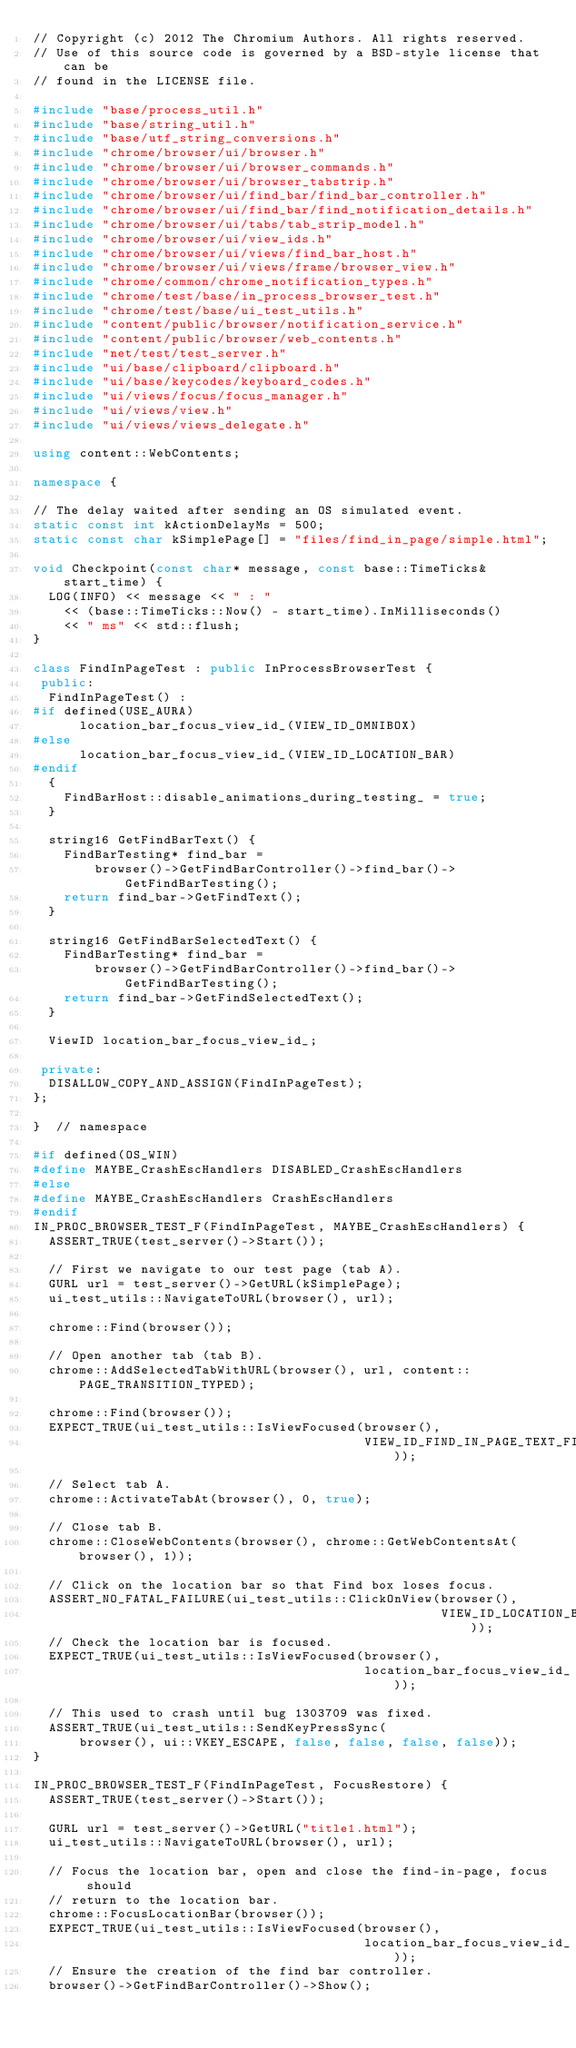Convert code to text. <code><loc_0><loc_0><loc_500><loc_500><_C++_>// Copyright (c) 2012 The Chromium Authors. All rights reserved.
// Use of this source code is governed by a BSD-style license that can be
// found in the LICENSE file.

#include "base/process_util.h"
#include "base/string_util.h"
#include "base/utf_string_conversions.h"
#include "chrome/browser/ui/browser.h"
#include "chrome/browser/ui/browser_commands.h"
#include "chrome/browser/ui/browser_tabstrip.h"
#include "chrome/browser/ui/find_bar/find_bar_controller.h"
#include "chrome/browser/ui/find_bar/find_notification_details.h"
#include "chrome/browser/ui/tabs/tab_strip_model.h"
#include "chrome/browser/ui/view_ids.h"
#include "chrome/browser/ui/views/find_bar_host.h"
#include "chrome/browser/ui/views/frame/browser_view.h"
#include "chrome/common/chrome_notification_types.h"
#include "chrome/test/base/in_process_browser_test.h"
#include "chrome/test/base/ui_test_utils.h"
#include "content/public/browser/notification_service.h"
#include "content/public/browser/web_contents.h"
#include "net/test/test_server.h"
#include "ui/base/clipboard/clipboard.h"
#include "ui/base/keycodes/keyboard_codes.h"
#include "ui/views/focus/focus_manager.h"
#include "ui/views/view.h"
#include "ui/views/views_delegate.h"

using content::WebContents;

namespace {

// The delay waited after sending an OS simulated event.
static const int kActionDelayMs = 500;
static const char kSimplePage[] = "files/find_in_page/simple.html";

void Checkpoint(const char* message, const base::TimeTicks& start_time) {
  LOG(INFO) << message << " : "
    << (base::TimeTicks::Now() - start_time).InMilliseconds()
    << " ms" << std::flush;
}

class FindInPageTest : public InProcessBrowserTest {
 public:
  FindInPageTest() :
#if defined(USE_AURA)
      location_bar_focus_view_id_(VIEW_ID_OMNIBOX)
#else
      location_bar_focus_view_id_(VIEW_ID_LOCATION_BAR)
#endif
  {
    FindBarHost::disable_animations_during_testing_ = true;
  }

  string16 GetFindBarText() {
    FindBarTesting* find_bar =
        browser()->GetFindBarController()->find_bar()->GetFindBarTesting();
    return find_bar->GetFindText();
  }

  string16 GetFindBarSelectedText() {
    FindBarTesting* find_bar =
        browser()->GetFindBarController()->find_bar()->GetFindBarTesting();
    return find_bar->GetFindSelectedText();
  }

  ViewID location_bar_focus_view_id_;

 private:
  DISALLOW_COPY_AND_ASSIGN(FindInPageTest);
};

}  // namespace

#if defined(OS_WIN)
#define MAYBE_CrashEscHandlers DISABLED_CrashEscHandlers
#else
#define MAYBE_CrashEscHandlers CrashEscHandlers
#endif
IN_PROC_BROWSER_TEST_F(FindInPageTest, MAYBE_CrashEscHandlers) {
  ASSERT_TRUE(test_server()->Start());

  // First we navigate to our test page (tab A).
  GURL url = test_server()->GetURL(kSimplePage);
  ui_test_utils::NavigateToURL(browser(), url);

  chrome::Find(browser());

  // Open another tab (tab B).
  chrome::AddSelectedTabWithURL(browser(), url, content::PAGE_TRANSITION_TYPED);

  chrome::Find(browser());
  EXPECT_TRUE(ui_test_utils::IsViewFocused(browser(),
                                           VIEW_ID_FIND_IN_PAGE_TEXT_FIELD));

  // Select tab A.
  chrome::ActivateTabAt(browser(), 0, true);

  // Close tab B.
  chrome::CloseWebContents(browser(), chrome::GetWebContentsAt(browser(), 1));

  // Click on the location bar so that Find box loses focus.
  ASSERT_NO_FATAL_FAILURE(ui_test_utils::ClickOnView(browser(),
                                                     VIEW_ID_LOCATION_BAR));
  // Check the location bar is focused.
  EXPECT_TRUE(ui_test_utils::IsViewFocused(browser(),
                                           location_bar_focus_view_id_));

  // This used to crash until bug 1303709 was fixed.
  ASSERT_TRUE(ui_test_utils::SendKeyPressSync(
      browser(), ui::VKEY_ESCAPE, false, false, false, false));
}

IN_PROC_BROWSER_TEST_F(FindInPageTest, FocusRestore) {
  ASSERT_TRUE(test_server()->Start());

  GURL url = test_server()->GetURL("title1.html");
  ui_test_utils::NavigateToURL(browser(), url);

  // Focus the location bar, open and close the find-in-page, focus should
  // return to the location bar.
  chrome::FocusLocationBar(browser());
  EXPECT_TRUE(ui_test_utils::IsViewFocused(browser(),
                                           location_bar_focus_view_id_));
  // Ensure the creation of the find bar controller.
  browser()->GetFindBarController()->Show();</code> 